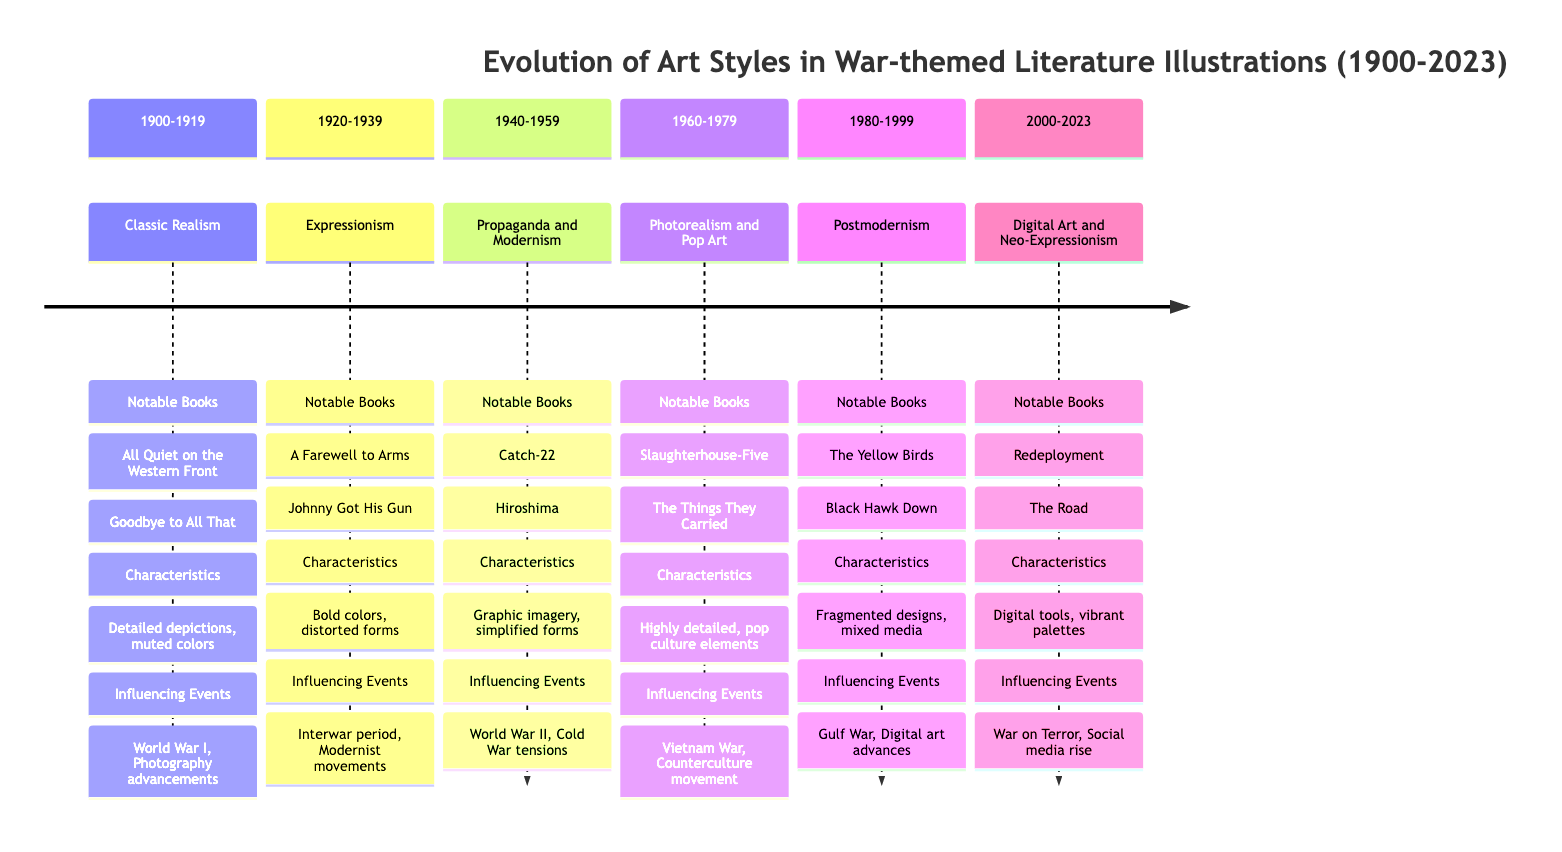What art style is represented from 1900 to 1919? The timeline clearly indicates that the art style for this period is "Classic Realism." It is stated in the time segment labeled "1900-1919."
Answer: Classic Realism Which book is notable for the Expressionism art style? The notable book listed under the Expressionism section (1920-1939) is "A Farewell to Arms" by Ernest Hemingway. This information is found in the corresponding section for that period.
Answer: A Farewell to Arms How many art styles are detailed in the timeline? By counting the sections provided in the timeline, there are six distinct art styles showcased from 1900 to 2023, each representing a different period.
Answer: six What is the primary influence on the art styles from 1940 to 1959? The timeline shows that the influencing events include "World War II" and "Cold War tensions," indicating these significant events shaped the art styles during that time.
Answer: World War II, Cold War tensions What is a key characteristic of art from 1980 to 1999? The timeline specifies that art from this period includes "Fragmented and abstract designs," which highlights a shift in how art represented war themes. This can be found in the characteristics section of the 1980-1999 timeline.
Answer: Fragmented and abstract designs Which two events influenced art from 2000 to 2023? The influencing events listed under the section for 2000-2023 are "War on Terror" and "Rise of social media and digital platforms," indicating how contemporary issues affected artistic representation in that period.
Answer: War on Terror, Rise of social media Which art style utilized bold colors and distorted forms? The art style that utilized these characteristics is "Expressionism," highlighted in the 1920-1939 segment. The characteristics section specifies the use of bold colors and distorted forms.
Answer: Expressionism What is the trend of illustration styles as we progress from 1900 to 2023? The trend shows a shift from "Classic Realism" at the start, focusing on grim realities, to "Digital Art and Neo-Expressionism" with vibrant color palettes by 2023, reflecting a change from realism to abstraction and modern techniques.
Answer: Shift from Classic Realism to Digital Art and Neo-Expressionism How does the art from 1960 to 1979 differ from that of 1980 to 1999 in terms of medium? Art from 1960 to 1979 emphasizes "Highly detailed, realistic images" and incorporates "contemporary pop culture elements," while the later period (1980-1999) is characterized by "Mixed media techniques," indicating a transition from realism to diverse media.
Answer: Realistic images vs. Mixed media techniques 